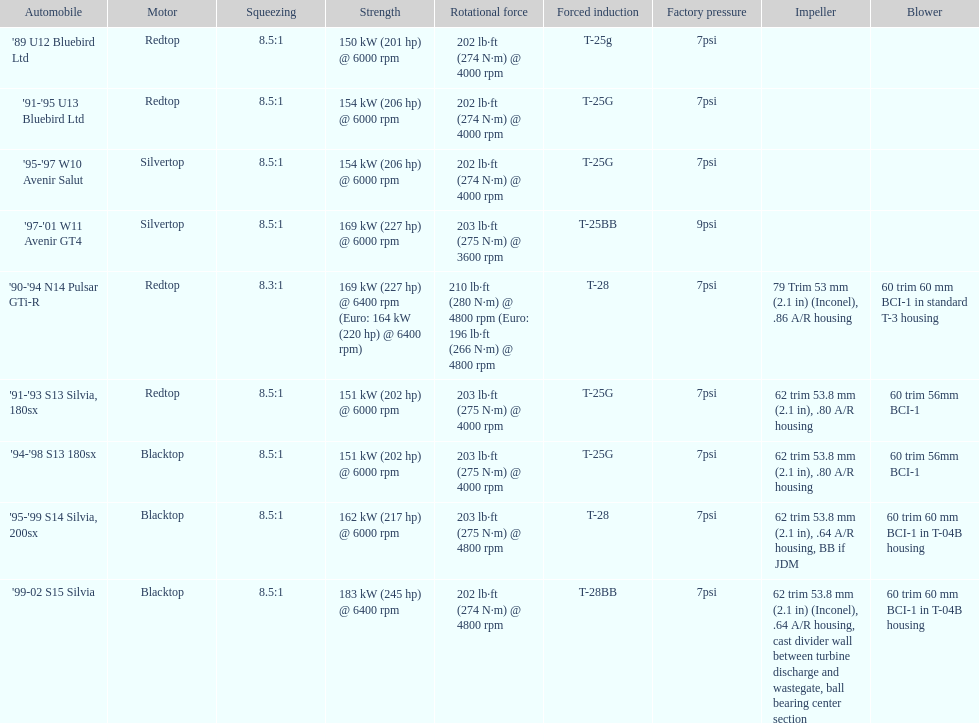Which engine possesses the lowest compression ratio? '90-'94 N14 Pulsar GTi-R. 